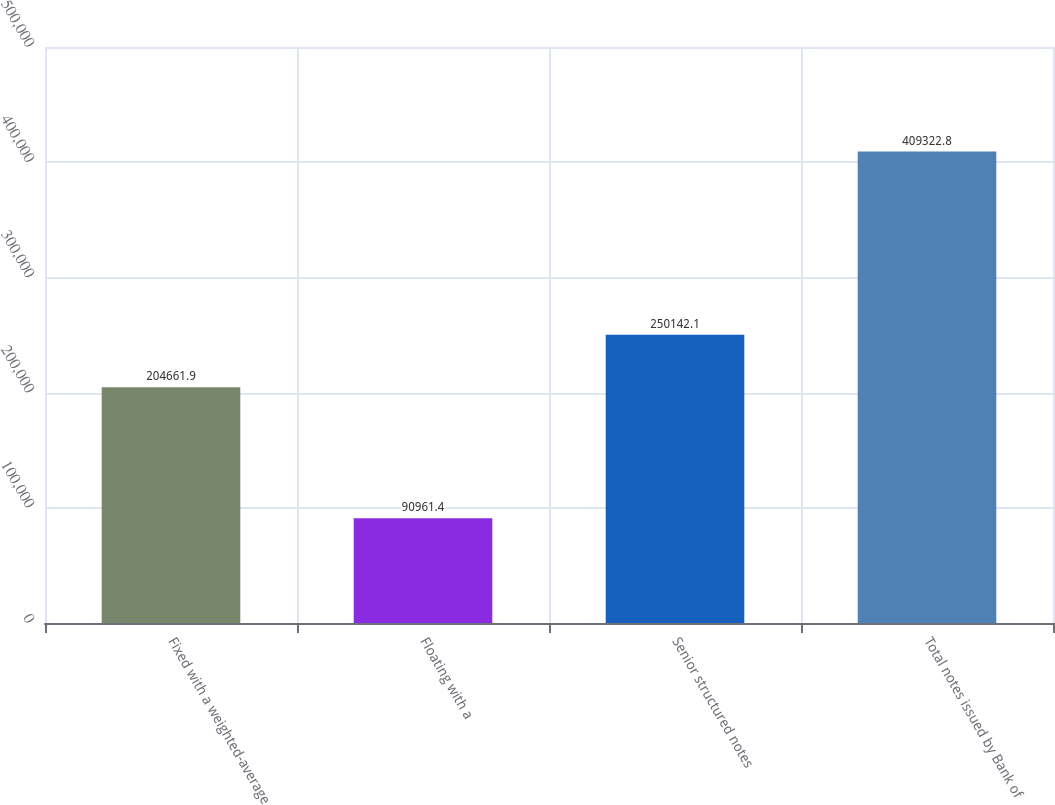Convert chart to OTSL. <chart><loc_0><loc_0><loc_500><loc_500><bar_chart><fcel>Fixed with a weighted-average<fcel>Floating with a<fcel>Senior structured notes<fcel>Total notes issued by Bank of<nl><fcel>204662<fcel>90961.4<fcel>250142<fcel>409323<nl></chart> 